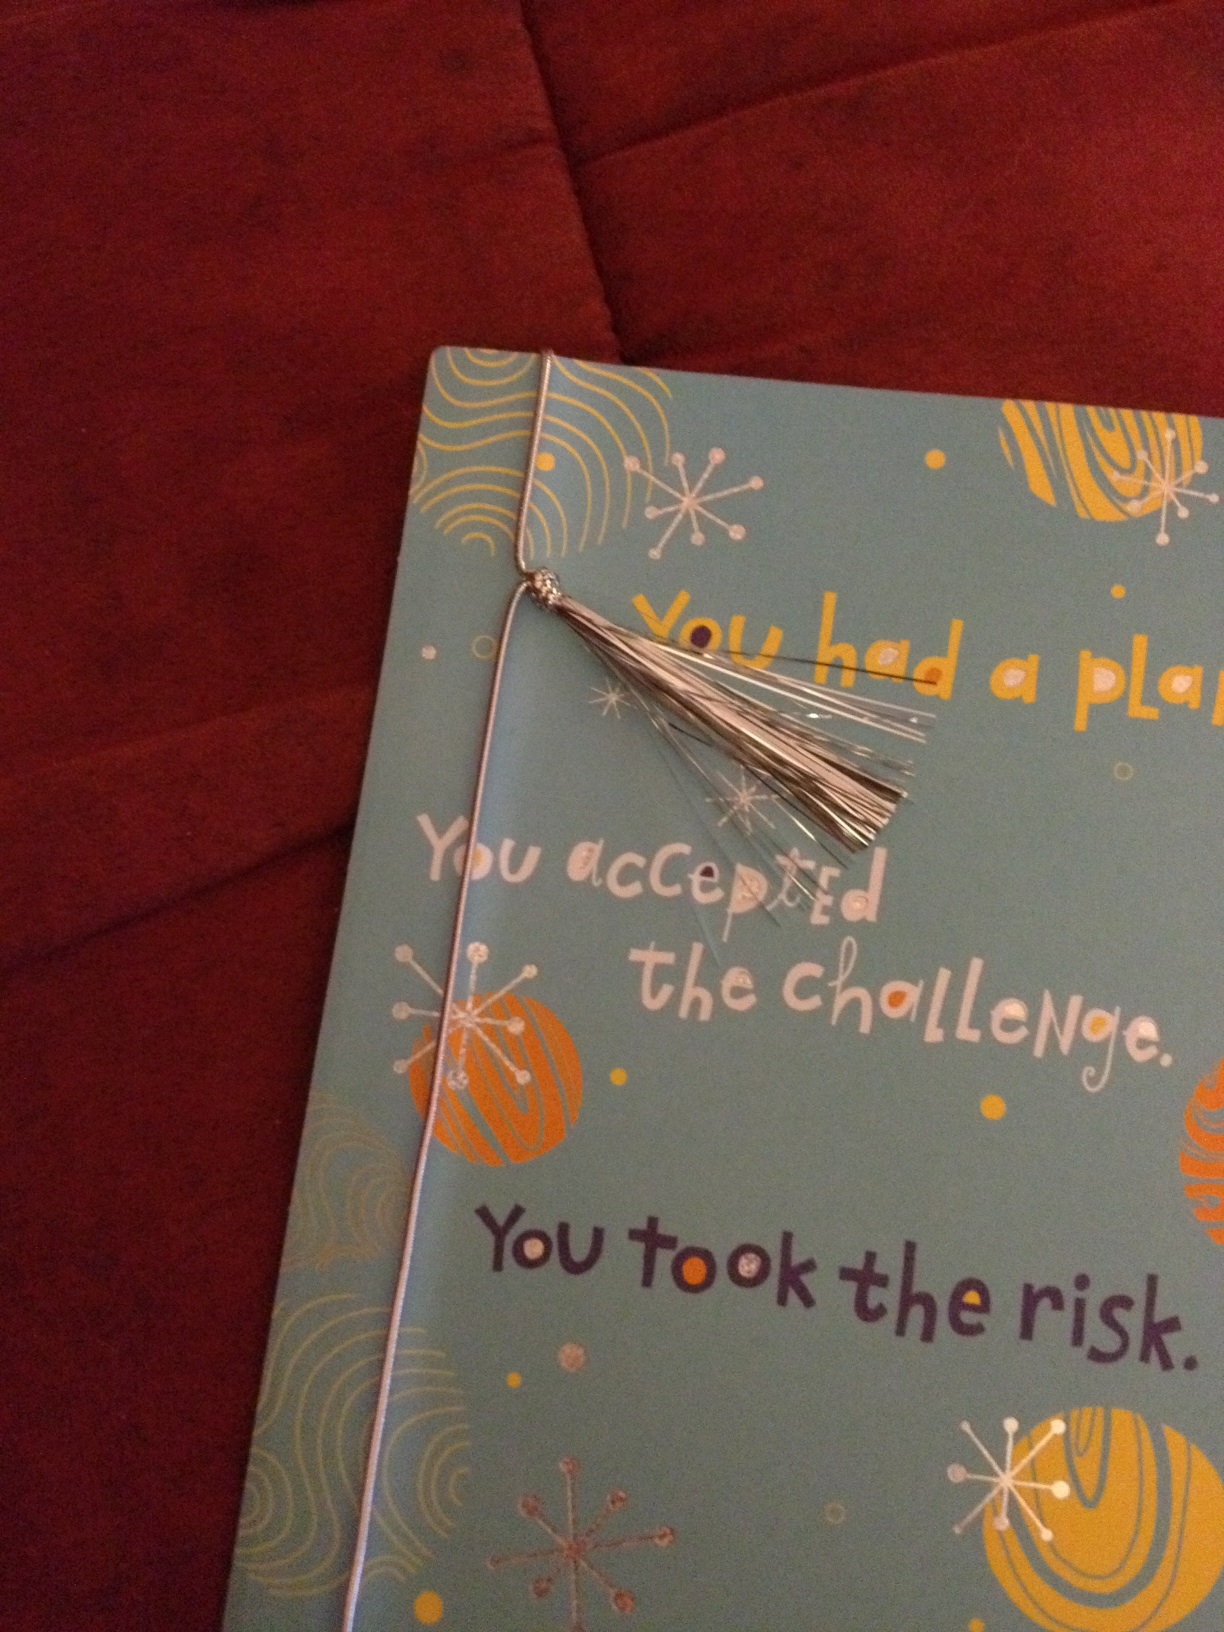Can you describe the design elements on this card? The card showcases a combination of modern and playful design elements. It has a background of light blue color with colorful abstract patterns, including circles and starburst designs in orange, white, and yellow. There is a shiny silver tassel attached to a string, adding a playful and celebratory touch. What does the text on the card suggest? The text on the card conveys a motivational and congratulatory message. It reads: 'You had a plan. You accepted the challenge. You took the risk.' This suggests that the card is intended to acknowledge and celebrate someone's bravery, planning, and determination in facing a challenge. In what context could this card be given? This card could be given in a variety of contexts such as after a significant achievement like graduating from a challenging program, completing a demanding project, or taking a bold step in one's career. It is perfect for recognizing someone's hard work, courage, and success in achieving their goals. 